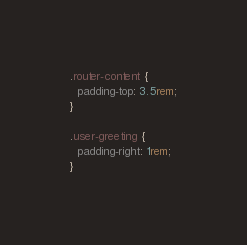<code> <loc_0><loc_0><loc_500><loc_500><_CSS_>.router-content {
  padding-top: 3.5rem;
}

.user-greeting {
  padding-right: 1rem;
}</code> 